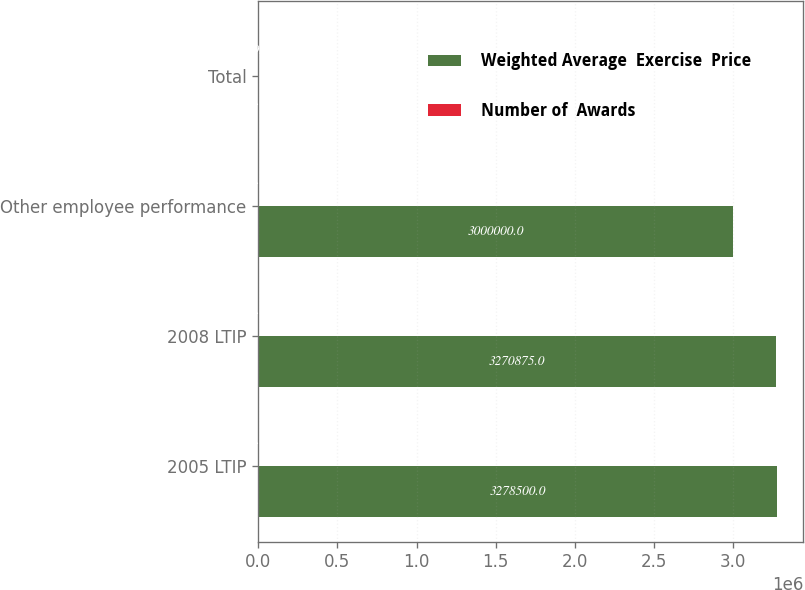<chart> <loc_0><loc_0><loc_500><loc_500><stacked_bar_chart><ecel><fcel>2005 LTIP<fcel>2008 LTIP<fcel>Other employee performance<fcel>Total<nl><fcel>Weighted Average  Exercise  Price<fcel>3.2785e+06<fcel>3.27088e+06<fcel>3e+06<fcel>23.16<nl><fcel>Number of  Awards<fcel>22.92<fcel>11.84<fcel>23.16<fcel>19.2<nl></chart> 